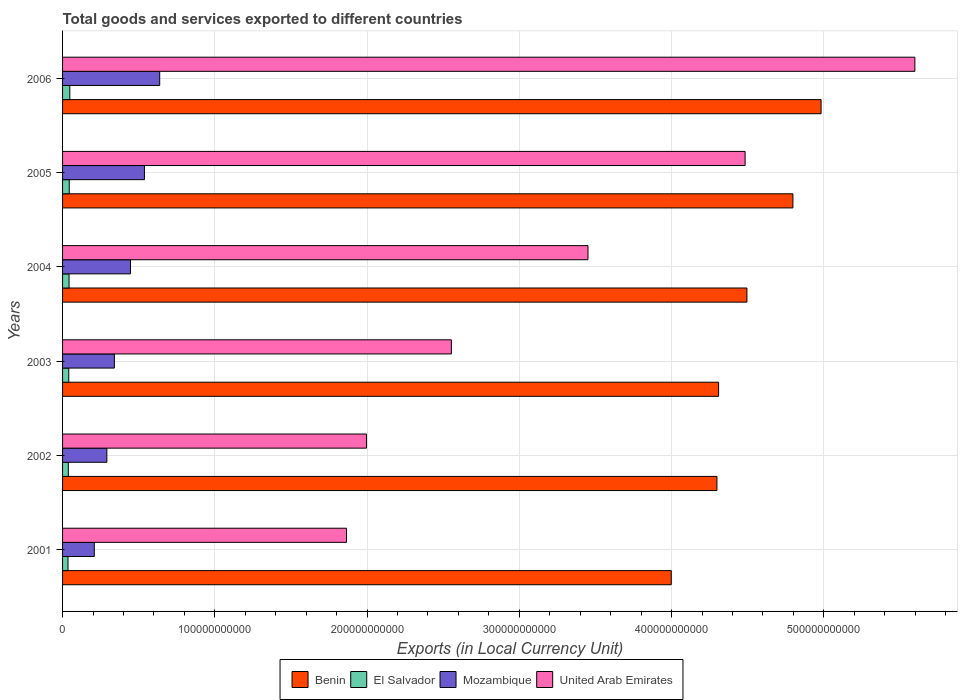How many groups of bars are there?
Your answer should be compact. 6. Are the number of bars per tick equal to the number of legend labels?
Give a very brief answer. Yes. Are the number of bars on each tick of the Y-axis equal?
Ensure brevity in your answer.  Yes. How many bars are there on the 4th tick from the top?
Ensure brevity in your answer.  4. What is the label of the 2nd group of bars from the top?
Give a very brief answer. 2005. In how many cases, is the number of bars for a given year not equal to the number of legend labels?
Make the answer very short. 0. What is the Amount of goods and services exports in El Salvador in 2002?
Give a very brief answer. 3.77e+09. Across all years, what is the maximum Amount of goods and services exports in El Salvador?
Your answer should be compact. 4.76e+09. Across all years, what is the minimum Amount of goods and services exports in United Arab Emirates?
Your answer should be very brief. 1.87e+11. In which year was the Amount of goods and services exports in United Arab Emirates maximum?
Make the answer very short. 2006. In which year was the Amount of goods and services exports in Mozambique minimum?
Your answer should be compact. 2001. What is the total Amount of goods and services exports in Mozambique in the graph?
Keep it short and to the point. 2.46e+11. What is the difference between the Amount of goods and services exports in United Arab Emirates in 2003 and that in 2005?
Make the answer very short. -1.93e+11. What is the difference between the Amount of goods and services exports in Mozambique in 2001 and the Amount of goods and services exports in El Salvador in 2003?
Keep it short and to the point. 1.68e+1. What is the average Amount of goods and services exports in Benin per year?
Provide a succinct answer. 4.48e+11. In the year 2002, what is the difference between the Amount of goods and services exports in El Salvador and Amount of goods and services exports in Mozambique?
Provide a succinct answer. -2.53e+1. What is the ratio of the Amount of goods and services exports in El Salvador in 2001 to that in 2005?
Ensure brevity in your answer.  0.81. Is the difference between the Amount of goods and services exports in El Salvador in 2001 and 2005 greater than the difference between the Amount of goods and services exports in Mozambique in 2001 and 2005?
Ensure brevity in your answer.  Yes. What is the difference between the highest and the second highest Amount of goods and services exports in United Arab Emirates?
Ensure brevity in your answer.  1.12e+11. What is the difference between the highest and the lowest Amount of goods and services exports in Mozambique?
Give a very brief answer. 4.30e+1. In how many years, is the Amount of goods and services exports in Mozambique greater than the average Amount of goods and services exports in Mozambique taken over all years?
Keep it short and to the point. 3. Is the sum of the Amount of goods and services exports in Benin in 2002 and 2003 greater than the maximum Amount of goods and services exports in El Salvador across all years?
Provide a short and direct response. Yes. Is it the case that in every year, the sum of the Amount of goods and services exports in United Arab Emirates and Amount of goods and services exports in Benin is greater than the sum of Amount of goods and services exports in Mozambique and Amount of goods and services exports in El Salvador?
Ensure brevity in your answer.  Yes. What does the 2nd bar from the top in 2003 represents?
Provide a short and direct response. Mozambique. What does the 3rd bar from the bottom in 2006 represents?
Offer a very short reply. Mozambique. Is it the case that in every year, the sum of the Amount of goods and services exports in United Arab Emirates and Amount of goods and services exports in El Salvador is greater than the Amount of goods and services exports in Mozambique?
Offer a terse response. Yes. What is the difference between two consecutive major ticks on the X-axis?
Your response must be concise. 1.00e+11. Are the values on the major ticks of X-axis written in scientific E-notation?
Offer a terse response. No. Does the graph contain any zero values?
Your answer should be compact. No. Does the graph contain grids?
Provide a short and direct response. Yes. Where does the legend appear in the graph?
Provide a short and direct response. Bottom center. How are the legend labels stacked?
Offer a very short reply. Horizontal. What is the title of the graph?
Offer a very short reply. Total goods and services exported to different countries. What is the label or title of the X-axis?
Provide a succinct answer. Exports (in Local Currency Unit). What is the label or title of the Y-axis?
Make the answer very short. Years. What is the Exports (in Local Currency Unit) in Benin in 2001?
Your response must be concise. 4.00e+11. What is the Exports (in Local Currency Unit) of El Salvador in 2001?
Your response must be concise. 3.57e+09. What is the Exports (in Local Currency Unit) of Mozambique in 2001?
Ensure brevity in your answer.  2.08e+1. What is the Exports (in Local Currency Unit) of United Arab Emirates in 2001?
Give a very brief answer. 1.87e+11. What is the Exports (in Local Currency Unit) in Benin in 2002?
Provide a succinct answer. 4.30e+11. What is the Exports (in Local Currency Unit) in El Salvador in 2002?
Provide a short and direct response. 3.77e+09. What is the Exports (in Local Currency Unit) of Mozambique in 2002?
Offer a terse response. 2.91e+1. What is the Exports (in Local Currency Unit) in United Arab Emirates in 2002?
Your answer should be compact. 2.00e+11. What is the Exports (in Local Currency Unit) of Benin in 2003?
Provide a succinct answer. 4.31e+11. What is the Exports (in Local Currency Unit) in El Salvador in 2003?
Give a very brief answer. 4.07e+09. What is the Exports (in Local Currency Unit) of Mozambique in 2003?
Provide a succinct answer. 3.40e+1. What is the Exports (in Local Currency Unit) of United Arab Emirates in 2003?
Your response must be concise. 2.55e+11. What is the Exports (in Local Currency Unit) in Benin in 2004?
Offer a very short reply. 4.50e+11. What is the Exports (in Local Currency Unit) in El Salvador in 2004?
Offer a terse response. 4.26e+09. What is the Exports (in Local Currency Unit) of Mozambique in 2004?
Your answer should be compact. 4.46e+1. What is the Exports (in Local Currency Unit) in United Arab Emirates in 2004?
Ensure brevity in your answer.  3.45e+11. What is the Exports (in Local Currency Unit) in Benin in 2005?
Provide a succinct answer. 4.80e+11. What is the Exports (in Local Currency Unit) in El Salvador in 2005?
Ensure brevity in your answer.  4.38e+09. What is the Exports (in Local Currency Unit) of Mozambique in 2005?
Your response must be concise. 5.38e+1. What is the Exports (in Local Currency Unit) in United Arab Emirates in 2005?
Your answer should be very brief. 4.48e+11. What is the Exports (in Local Currency Unit) of Benin in 2006?
Your answer should be compact. 4.98e+11. What is the Exports (in Local Currency Unit) of El Salvador in 2006?
Your answer should be compact. 4.76e+09. What is the Exports (in Local Currency Unit) in Mozambique in 2006?
Make the answer very short. 6.38e+1. What is the Exports (in Local Currency Unit) of United Arab Emirates in 2006?
Give a very brief answer. 5.60e+11. Across all years, what is the maximum Exports (in Local Currency Unit) of Benin?
Ensure brevity in your answer.  4.98e+11. Across all years, what is the maximum Exports (in Local Currency Unit) in El Salvador?
Give a very brief answer. 4.76e+09. Across all years, what is the maximum Exports (in Local Currency Unit) in Mozambique?
Your answer should be compact. 6.38e+1. Across all years, what is the maximum Exports (in Local Currency Unit) of United Arab Emirates?
Offer a very short reply. 5.60e+11. Across all years, what is the minimum Exports (in Local Currency Unit) of Benin?
Your answer should be very brief. 4.00e+11. Across all years, what is the minimum Exports (in Local Currency Unit) of El Salvador?
Provide a short and direct response. 3.57e+09. Across all years, what is the minimum Exports (in Local Currency Unit) in Mozambique?
Your response must be concise. 2.08e+1. Across all years, what is the minimum Exports (in Local Currency Unit) in United Arab Emirates?
Your response must be concise. 1.87e+11. What is the total Exports (in Local Currency Unit) in Benin in the graph?
Provide a succinct answer. 2.69e+12. What is the total Exports (in Local Currency Unit) of El Salvador in the graph?
Your answer should be compact. 2.48e+1. What is the total Exports (in Local Currency Unit) in Mozambique in the graph?
Make the answer very short. 2.46e+11. What is the total Exports (in Local Currency Unit) in United Arab Emirates in the graph?
Make the answer very short. 1.99e+12. What is the difference between the Exports (in Local Currency Unit) in Benin in 2001 and that in 2002?
Keep it short and to the point. -3.00e+1. What is the difference between the Exports (in Local Currency Unit) of El Salvador in 2001 and that in 2002?
Your response must be concise. -2.04e+08. What is the difference between the Exports (in Local Currency Unit) of Mozambique in 2001 and that in 2002?
Keep it short and to the point. -8.24e+09. What is the difference between the Exports (in Local Currency Unit) in United Arab Emirates in 2001 and that in 2002?
Keep it short and to the point. -1.31e+1. What is the difference between the Exports (in Local Currency Unit) in Benin in 2001 and that in 2003?
Your answer should be very brief. -3.11e+1. What is the difference between the Exports (in Local Currency Unit) in El Salvador in 2001 and that in 2003?
Your answer should be very brief. -5.05e+08. What is the difference between the Exports (in Local Currency Unit) of Mozambique in 2001 and that in 2003?
Make the answer very short. -1.32e+1. What is the difference between the Exports (in Local Currency Unit) of United Arab Emirates in 2001 and that in 2003?
Your response must be concise. -6.89e+1. What is the difference between the Exports (in Local Currency Unit) in Benin in 2001 and that in 2004?
Offer a very short reply. -4.97e+1. What is the difference between the Exports (in Local Currency Unit) of El Salvador in 2001 and that in 2004?
Offer a terse response. -6.91e+08. What is the difference between the Exports (in Local Currency Unit) in Mozambique in 2001 and that in 2004?
Give a very brief answer. -2.38e+1. What is the difference between the Exports (in Local Currency Unit) of United Arab Emirates in 2001 and that in 2004?
Provide a succinct answer. -1.59e+11. What is the difference between the Exports (in Local Currency Unit) of Benin in 2001 and that in 2005?
Offer a very short reply. -7.99e+1. What is the difference between the Exports (in Local Currency Unit) in El Salvador in 2001 and that in 2005?
Ensure brevity in your answer.  -8.15e+08. What is the difference between the Exports (in Local Currency Unit) in Mozambique in 2001 and that in 2005?
Your answer should be compact. -3.29e+1. What is the difference between the Exports (in Local Currency Unit) in United Arab Emirates in 2001 and that in 2005?
Provide a short and direct response. -2.62e+11. What is the difference between the Exports (in Local Currency Unit) in Benin in 2001 and that in 2006?
Give a very brief answer. -9.84e+1. What is the difference between the Exports (in Local Currency Unit) in El Salvador in 2001 and that in 2006?
Offer a terse response. -1.20e+09. What is the difference between the Exports (in Local Currency Unit) in Mozambique in 2001 and that in 2006?
Your answer should be very brief. -4.30e+1. What is the difference between the Exports (in Local Currency Unit) in United Arab Emirates in 2001 and that in 2006?
Your answer should be very brief. -3.73e+11. What is the difference between the Exports (in Local Currency Unit) in Benin in 2002 and that in 2003?
Your response must be concise. -1.10e+09. What is the difference between the Exports (in Local Currency Unit) in El Salvador in 2002 and that in 2003?
Provide a succinct answer. -3.01e+08. What is the difference between the Exports (in Local Currency Unit) of Mozambique in 2002 and that in 2003?
Offer a very short reply. -4.95e+09. What is the difference between the Exports (in Local Currency Unit) in United Arab Emirates in 2002 and that in 2003?
Keep it short and to the point. -5.57e+1. What is the difference between the Exports (in Local Currency Unit) in Benin in 2002 and that in 2004?
Offer a very short reply. -1.97e+1. What is the difference between the Exports (in Local Currency Unit) in El Salvador in 2002 and that in 2004?
Make the answer very short. -4.87e+08. What is the difference between the Exports (in Local Currency Unit) in Mozambique in 2002 and that in 2004?
Ensure brevity in your answer.  -1.55e+1. What is the difference between the Exports (in Local Currency Unit) of United Arab Emirates in 2002 and that in 2004?
Keep it short and to the point. -1.45e+11. What is the difference between the Exports (in Local Currency Unit) in Benin in 2002 and that in 2005?
Offer a very short reply. -4.99e+1. What is the difference between the Exports (in Local Currency Unit) in El Salvador in 2002 and that in 2005?
Offer a terse response. -6.11e+08. What is the difference between the Exports (in Local Currency Unit) of Mozambique in 2002 and that in 2005?
Your answer should be compact. -2.47e+1. What is the difference between the Exports (in Local Currency Unit) in United Arab Emirates in 2002 and that in 2005?
Ensure brevity in your answer.  -2.49e+11. What is the difference between the Exports (in Local Currency Unit) in Benin in 2002 and that in 2006?
Keep it short and to the point. -6.84e+1. What is the difference between the Exports (in Local Currency Unit) of El Salvador in 2002 and that in 2006?
Provide a succinct answer. -9.92e+08. What is the difference between the Exports (in Local Currency Unit) of Mozambique in 2002 and that in 2006?
Your answer should be compact. -3.47e+1. What is the difference between the Exports (in Local Currency Unit) in United Arab Emirates in 2002 and that in 2006?
Offer a very short reply. -3.60e+11. What is the difference between the Exports (in Local Currency Unit) of Benin in 2003 and that in 2004?
Provide a short and direct response. -1.86e+1. What is the difference between the Exports (in Local Currency Unit) in El Salvador in 2003 and that in 2004?
Provide a succinct answer. -1.86e+08. What is the difference between the Exports (in Local Currency Unit) of Mozambique in 2003 and that in 2004?
Your answer should be compact. -1.06e+1. What is the difference between the Exports (in Local Currency Unit) of United Arab Emirates in 2003 and that in 2004?
Offer a terse response. -8.97e+1. What is the difference between the Exports (in Local Currency Unit) of Benin in 2003 and that in 2005?
Your response must be concise. -4.88e+1. What is the difference between the Exports (in Local Currency Unit) in El Salvador in 2003 and that in 2005?
Your answer should be very brief. -3.10e+08. What is the difference between the Exports (in Local Currency Unit) of Mozambique in 2003 and that in 2005?
Your answer should be very brief. -1.97e+1. What is the difference between the Exports (in Local Currency Unit) of United Arab Emirates in 2003 and that in 2005?
Offer a terse response. -1.93e+11. What is the difference between the Exports (in Local Currency Unit) in Benin in 2003 and that in 2006?
Give a very brief answer. -6.73e+1. What is the difference between the Exports (in Local Currency Unit) in El Salvador in 2003 and that in 2006?
Provide a succinct answer. -6.91e+08. What is the difference between the Exports (in Local Currency Unit) of Mozambique in 2003 and that in 2006?
Your answer should be compact. -2.98e+1. What is the difference between the Exports (in Local Currency Unit) of United Arab Emirates in 2003 and that in 2006?
Give a very brief answer. -3.04e+11. What is the difference between the Exports (in Local Currency Unit) of Benin in 2004 and that in 2005?
Ensure brevity in your answer.  -3.02e+1. What is the difference between the Exports (in Local Currency Unit) in El Salvador in 2004 and that in 2005?
Ensure brevity in your answer.  -1.24e+08. What is the difference between the Exports (in Local Currency Unit) in Mozambique in 2004 and that in 2005?
Your answer should be very brief. -9.15e+09. What is the difference between the Exports (in Local Currency Unit) of United Arab Emirates in 2004 and that in 2005?
Your response must be concise. -1.03e+11. What is the difference between the Exports (in Local Currency Unit) in Benin in 2004 and that in 2006?
Your answer should be very brief. -4.87e+1. What is the difference between the Exports (in Local Currency Unit) in El Salvador in 2004 and that in 2006?
Provide a succinct answer. -5.05e+08. What is the difference between the Exports (in Local Currency Unit) in Mozambique in 2004 and that in 2006?
Offer a very short reply. -1.92e+1. What is the difference between the Exports (in Local Currency Unit) of United Arab Emirates in 2004 and that in 2006?
Offer a very short reply. -2.15e+11. What is the difference between the Exports (in Local Currency Unit) of Benin in 2005 and that in 2006?
Your answer should be compact. -1.85e+1. What is the difference between the Exports (in Local Currency Unit) of El Salvador in 2005 and that in 2006?
Ensure brevity in your answer.  -3.81e+08. What is the difference between the Exports (in Local Currency Unit) in Mozambique in 2005 and that in 2006?
Make the answer very short. -1.00e+1. What is the difference between the Exports (in Local Currency Unit) in United Arab Emirates in 2005 and that in 2006?
Give a very brief answer. -1.12e+11. What is the difference between the Exports (in Local Currency Unit) of Benin in 2001 and the Exports (in Local Currency Unit) of El Salvador in 2002?
Your response must be concise. 3.96e+11. What is the difference between the Exports (in Local Currency Unit) of Benin in 2001 and the Exports (in Local Currency Unit) of Mozambique in 2002?
Make the answer very short. 3.71e+11. What is the difference between the Exports (in Local Currency Unit) in Benin in 2001 and the Exports (in Local Currency Unit) in United Arab Emirates in 2002?
Make the answer very short. 2.00e+11. What is the difference between the Exports (in Local Currency Unit) in El Salvador in 2001 and the Exports (in Local Currency Unit) in Mozambique in 2002?
Offer a terse response. -2.55e+1. What is the difference between the Exports (in Local Currency Unit) of El Salvador in 2001 and the Exports (in Local Currency Unit) of United Arab Emirates in 2002?
Offer a very short reply. -1.96e+11. What is the difference between the Exports (in Local Currency Unit) in Mozambique in 2001 and the Exports (in Local Currency Unit) in United Arab Emirates in 2002?
Provide a succinct answer. -1.79e+11. What is the difference between the Exports (in Local Currency Unit) in Benin in 2001 and the Exports (in Local Currency Unit) in El Salvador in 2003?
Make the answer very short. 3.96e+11. What is the difference between the Exports (in Local Currency Unit) in Benin in 2001 and the Exports (in Local Currency Unit) in Mozambique in 2003?
Offer a terse response. 3.66e+11. What is the difference between the Exports (in Local Currency Unit) of Benin in 2001 and the Exports (in Local Currency Unit) of United Arab Emirates in 2003?
Give a very brief answer. 1.44e+11. What is the difference between the Exports (in Local Currency Unit) in El Salvador in 2001 and the Exports (in Local Currency Unit) in Mozambique in 2003?
Your answer should be very brief. -3.05e+1. What is the difference between the Exports (in Local Currency Unit) of El Salvador in 2001 and the Exports (in Local Currency Unit) of United Arab Emirates in 2003?
Keep it short and to the point. -2.52e+11. What is the difference between the Exports (in Local Currency Unit) of Mozambique in 2001 and the Exports (in Local Currency Unit) of United Arab Emirates in 2003?
Offer a very short reply. -2.35e+11. What is the difference between the Exports (in Local Currency Unit) in Benin in 2001 and the Exports (in Local Currency Unit) in El Salvador in 2004?
Provide a succinct answer. 3.96e+11. What is the difference between the Exports (in Local Currency Unit) of Benin in 2001 and the Exports (in Local Currency Unit) of Mozambique in 2004?
Offer a very short reply. 3.55e+11. What is the difference between the Exports (in Local Currency Unit) in Benin in 2001 and the Exports (in Local Currency Unit) in United Arab Emirates in 2004?
Give a very brief answer. 5.47e+1. What is the difference between the Exports (in Local Currency Unit) in El Salvador in 2001 and the Exports (in Local Currency Unit) in Mozambique in 2004?
Provide a succinct answer. -4.11e+1. What is the difference between the Exports (in Local Currency Unit) in El Salvador in 2001 and the Exports (in Local Currency Unit) in United Arab Emirates in 2004?
Give a very brief answer. -3.42e+11. What is the difference between the Exports (in Local Currency Unit) in Mozambique in 2001 and the Exports (in Local Currency Unit) in United Arab Emirates in 2004?
Provide a succinct answer. -3.24e+11. What is the difference between the Exports (in Local Currency Unit) of Benin in 2001 and the Exports (in Local Currency Unit) of El Salvador in 2005?
Provide a succinct answer. 3.95e+11. What is the difference between the Exports (in Local Currency Unit) in Benin in 2001 and the Exports (in Local Currency Unit) in Mozambique in 2005?
Keep it short and to the point. 3.46e+11. What is the difference between the Exports (in Local Currency Unit) of Benin in 2001 and the Exports (in Local Currency Unit) of United Arab Emirates in 2005?
Give a very brief answer. -4.85e+1. What is the difference between the Exports (in Local Currency Unit) of El Salvador in 2001 and the Exports (in Local Currency Unit) of Mozambique in 2005?
Give a very brief answer. -5.02e+1. What is the difference between the Exports (in Local Currency Unit) of El Salvador in 2001 and the Exports (in Local Currency Unit) of United Arab Emirates in 2005?
Your answer should be very brief. -4.45e+11. What is the difference between the Exports (in Local Currency Unit) of Mozambique in 2001 and the Exports (in Local Currency Unit) of United Arab Emirates in 2005?
Your answer should be compact. -4.27e+11. What is the difference between the Exports (in Local Currency Unit) in Benin in 2001 and the Exports (in Local Currency Unit) in El Salvador in 2006?
Your answer should be compact. 3.95e+11. What is the difference between the Exports (in Local Currency Unit) of Benin in 2001 and the Exports (in Local Currency Unit) of Mozambique in 2006?
Offer a very short reply. 3.36e+11. What is the difference between the Exports (in Local Currency Unit) in Benin in 2001 and the Exports (in Local Currency Unit) in United Arab Emirates in 2006?
Offer a very short reply. -1.60e+11. What is the difference between the Exports (in Local Currency Unit) in El Salvador in 2001 and the Exports (in Local Currency Unit) in Mozambique in 2006?
Provide a succinct answer. -6.02e+1. What is the difference between the Exports (in Local Currency Unit) in El Salvador in 2001 and the Exports (in Local Currency Unit) in United Arab Emirates in 2006?
Make the answer very short. -5.56e+11. What is the difference between the Exports (in Local Currency Unit) of Mozambique in 2001 and the Exports (in Local Currency Unit) of United Arab Emirates in 2006?
Your answer should be very brief. -5.39e+11. What is the difference between the Exports (in Local Currency Unit) in Benin in 2002 and the Exports (in Local Currency Unit) in El Salvador in 2003?
Make the answer very short. 4.26e+11. What is the difference between the Exports (in Local Currency Unit) in Benin in 2002 and the Exports (in Local Currency Unit) in Mozambique in 2003?
Ensure brevity in your answer.  3.96e+11. What is the difference between the Exports (in Local Currency Unit) in Benin in 2002 and the Exports (in Local Currency Unit) in United Arab Emirates in 2003?
Provide a short and direct response. 1.74e+11. What is the difference between the Exports (in Local Currency Unit) in El Salvador in 2002 and the Exports (in Local Currency Unit) in Mozambique in 2003?
Give a very brief answer. -3.03e+1. What is the difference between the Exports (in Local Currency Unit) of El Salvador in 2002 and the Exports (in Local Currency Unit) of United Arab Emirates in 2003?
Give a very brief answer. -2.52e+11. What is the difference between the Exports (in Local Currency Unit) of Mozambique in 2002 and the Exports (in Local Currency Unit) of United Arab Emirates in 2003?
Provide a short and direct response. -2.26e+11. What is the difference between the Exports (in Local Currency Unit) of Benin in 2002 and the Exports (in Local Currency Unit) of El Salvador in 2004?
Offer a very short reply. 4.26e+11. What is the difference between the Exports (in Local Currency Unit) of Benin in 2002 and the Exports (in Local Currency Unit) of Mozambique in 2004?
Make the answer very short. 3.85e+11. What is the difference between the Exports (in Local Currency Unit) in Benin in 2002 and the Exports (in Local Currency Unit) in United Arab Emirates in 2004?
Offer a very short reply. 8.47e+1. What is the difference between the Exports (in Local Currency Unit) in El Salvador in 2002 and the Exports (in Local Currency Unit) in Mozambique in 2004?
Provide a succinct answer. -4.09e+1. What is the difference between the Exports (in Local Currency Unit) of El Salvador in 2002 and the Exports (in Local Currency Unit) of United Arab Emirates in 2004?
Provide a short and direct response. -3.41e+11. What is the difference between the Exports (in Local Currency Unit) of Mozambique in 2002 and the Exports (in Local Currency Unit) of United Arab Emirates in 2004?
Ensure brevity in your answer.  -3.16e+11. What is the difference between the Exports (in Local Currency Unit) in Benin in 2002 and the Exports (in Local Currency Unit) in El Salvador in 2005?
Offer a very short reply. 4.25e+11. What is the difference between the Exports (in Local Currency Unit) in Benin in 2002 and the Exports (in Local Currency Unit) in Mozambique in 2005?
Your answer should be compact. 3.76e+11. What is the difference between the Exports (in Local Currency Unit) in Benin in 2002 and the Exports (in Local Currency Unit) in United Arab Emirates in 2005?
Keep it short and to the point. -1.85e+1. What is the difference between the Exports (in Local Currency Unit) in El Salvador in 2002 and the Exports (in Local Currency Unit) in Mozambique in 2005?
Provide a short and direct response. -5.00e+1. What is the difference between the Exports (in Local Currency Unit) in El Salvador in 2002 and the Exports (in Local Currency Unit) in United Arab Emirates in 2005?
Ensure brevity in your answer.  -4.45e+11. What is the difference between the Exports (in Local Currency Unit) in Mozambique in 2002 and the Exports (in Local Currency Unit) in United Arab Emirates in 2005?
Make the answer very short. -4.19e+11. What is the difference between the Exports (in Local Currency Unit) in Benin in 2002 and the Exports (in Local Currency Unit) in El Salvador in 2006?
Your answer should be very brief. 4.25e+11. What is the difference between the Exports (in Local Currency Unit) in Benin in 2002 and the Exports (in Local Currency Unit) in Mozambique in 2006?
Keep it short and to the point. 3.66e+11. What is the difference between the Exports (in Local Currency Unit) of Benin in 2002 and the Exports (in Local Currency Unit) of United Arab Emirates in 2006?
Ensure brevity in your answer.  -1.30e+11. What is the difference between the Exports (in Local Currency Unit) in El Salvador in 2002 and the Exports (in Local Currency Unit) in Mozambique in 2006?
Provide a succinct answer. -6.00e+1. What is the difference between the Exports (in Local Currency Unit) in El Salvador in 2002 and the Exports (in Local Currency Unit) in United Arab Emirates in 2006?
Ensure brevity in your answer.  -5.56e+11. What is the difference between the Exports (in Local Currency Unit) of Mozambique in 2002 and the Exports (in Local Currency Unit) of United Arab Emirates in 2006?
Your response must be concise. -5.31e+11. What is the difference between the Exports (in Local Currency Unit) of Benin in 2003 and the Exports (in Local Currency Unit) of El Salvador in 2004?
Your answer should be compact. 4.27e+11. What is the difference between the Exports (in Local Currency Unit) of Benin in 2003 and the Exports (in Local Currency Unit) of Mozambique in 2004?
Provide a short and direct response. 3.86e+11. What is the difference between the Exports (in Local Currency Unit) of Benin in 2003 and the Exports (in Local Currency Unit) of United Arab Emirates in 2004?
Your response must be concise. 8.58e+1. What is the difference between the Exports (in Local Currency Unit) of El Salvador in 2003 and the Exports (in Local Currency Unit) of Mozambique in 2004?
Keep it short and to the point. -4.06e+1. What is the difference between the Exports (in Local Currency Unit) of El Salvador in 2003 and the Exports (in Local Currency Unit) of United Arab Emirates in 2004?
Keep it short and to the point. -3.41e+11. What is the difference between the Exports (in Local Currency Unit) in Mozambique in 2003 and the Exports (in Local Currency Unit) in United Arab Emirates in 2004?
Ensure brevity in your answer.  -3.11e+11. What is the difference between the Exports (in Local Currency Unit) of Benin in 2003 and the Exports (in Local Currency Unit) of El Salvador in 2005?
Ensure brevity in your answer.  4.27e+11. What is the difference between the Exports (in Local Currency Unit) in Benin in 2003 and the Exports (in Local Currency Unit) in Mozambique in 2005?
Your answer should be compact. 3.77e+11. What is the difference between the Exports (in Local Currency Unit) of Benin in 2003 and the Exports (in Local Currency Unit) of United Arab Emirates in 2005?
Keep it short and to the point. -1.74e+1. What is the difference between the Exports (in Local Currency Unit) of El Salvador in 2003 and the Exports (in Local Currency Unit) of Mozambique in 2005?
Your answer should be compact. -4.97e+1. What is the difference between the Exports (in Local Currency Unit) of El Salvador in 2003 and the Exports (in Local Currency Unit) of United Arab Emirates in 2005?
Your answer should be compact. -4.44e+11. What is the difference between the Exports (in Local Currency Unit) of Mozambique in 2003 and the Exports (in Local Currency Unit) of United Arab Emirates in 2005?
Your answer should be compact. -4.14e+11. What is the difference between the Exports (in Local Currency Unit) in Benin in 2003 and the Exports (in Local Currency Unit) in El Salvador in 2006?
Your answer should be very brief. 4.26e+11. What is the difference between the Exports (in Local Currency Unit) in Benin in 2003 and the Exports (in Local Currency Unit) in Mozambique in 2006?
Provide a succinct answer. 3.67e+11. What is the difference between the Exports (in Local Currency Unit) in Benin in 2003 and the Exports (in Local Currency Unit) in United Arab Emirates in 2006?
Keep it short and to the point. -1.29e+11. What is the difference between the Exports (in Local Currency Unit) in El Salvador in 2003 and the Exports (in Local Currency Unit) in Mozambique in 2006?
Give a very brief answer. -5.97e+1. What is the difference between the Exports (in Local Currency Unit) of El Salvador in 2003 and the Exports (in Local Currency Unit) of United Arab Emirates in 2006?
Make the answer very short. -5.56e+11. What is the difference between the Exports (in Local Currency Unit) of Mozambique in 2003 and the Exports (in Local Currency Unit) of United Arab Emirates in 2006?
Ensure brevity in your answer.  -5.26e+11. What is the difference between the Exports (in Local Currency Unit) in Benin in 2004 and the Exports (in Local Currency Unit) in El Salvador in 2005?
Your response must be concise. 4.45e+11. What is the difference between the Exports (in Local Currency Unit) of Benin in 2004 and the Exports (in Local Currency Unit) of Mozambique in 2005?
Your answer should be compact. 3.96e+11. What is the difference between the Exports (in Local Currency Unit) of Benin in 2004 and the Exports (in Local Currency Unit) of United Arab Emirates in 2005?
Provide a succinct answer. 1.20e+09. What is the difference between the Exports (in Local Currency Unit) in El Salvador in 2004 and the Exports (in Local Currency Unit) in Mozambique in 2005?
Ensure brevity in your answer.  -4.95e+1. What is the difference between the Exports (in Local Currency Unit) in El Salvador in 2004 and the Exports (in Local Currency Unit) in United Arab Emirates in 2005?
Your answer should be compact. -4.44e+11. What is the difference between the Exports (in Local Currency Unit) of Mozambique in 2004 and the Exports (in Local Currency Unit) of United Arab Emirates in 2005?
Ensure brevity in your answer.  -4.04e+11. What is the difference between the Exports (in Local Currency Unit) in Benin in 2004 and the Exports (in Local Currency Unit) in El Salvador in 2006?
Your answer should be very brief. 4.45e+11. What is the difference between the Exports (in Local Currency Unit) of Benin in 2004 and the Exports (in Local Currency Unit) of Mozambique in 2006?
Make the answer very short. 3.86e+11. What is the difference between the Exports (in Local Currency Unit) in Benin in 2004 and the Exports (in Local Currency Unit) in United Arab Emirates in 2006?
Your response must be concise. -1.10e+11. What is the difference between the Exports (in Local Currency Unit) in El Salvador in 2004 and the Exports (in Local Currency Unit) in Mozambique in 2006?
Ensure brevity in your answer.  -5.95e+1. What is the difference between the Exports (in Local Currency Unit) in El Salvador in 2004 and the Exports (in Local Currency Unit) in United Arab Emirates in 2006?
Make the answer very short. -5.56e+11. What is the difference between the Exports (in Local Currency Unit) in Mozambique in 2004 and the Exports (in Local Currency Unit) in United Arab Emirates in 2006?
Offer a very short reply. -5.15e+11. What is the difference between the Exports (in Local Currency Unit) in Benin in 2005 and the Exports (in Local Currency Unit) in El Salvador in 2006?
Make the answer very short. 4.75e+11. What is the difference between the Exports (in Local Currency Unit) of Benin in 2005 and the Exports (in Local Currency Unit) of Mozambique in 2006?
Offer a terse response. 4.16e+11. What is the difference between the Exports (in Local Currency Unit) of Benin in 2005 and the Exports (in Local Currency Unit) of United Arab Emirates in 2006?
Your answer should be very brief. -8.01e+1. What is the difference between the Exports (in Local Currency Unit) of El Salvador in 2005 and the Exports (in Local Currency Unit) of Mozambique in 2006?
Provide a succinct answer. -5.94e+1. What is the difference between the Exports (in Local Currency Unit) of El Salvador in 2005 and the Exports (in Local Currency Unit) of United Arab Emirates in 2006?
Keep it short and to the point. -5.55e+11. What is the difference between the Exports (in Local Currency Unit) in Mozambique in 2005 and the Exports (in Local Currency Unit) in United Arab Emirates in 2006?
Offer a terse response. -5.06e+11. What is the average Exports (in Local Currency Unit) in Benin per year?
Your response must be concise. 4.48e+11. What is the average Exports (in Local Currency Unit) in El Salvador per year?
Offer a terse response. 4.14e+09. What is the average Exports (in Local Currency Unit) in Mozambique per year?
Keep it short and to the point. 4.10e+1. What is the average Exports (in Local Currency Unit) in United Arab Emirates per year?
Provide a short and direct response. 3.32e+11. In the year 2001, what is the difference between the Exports (in Local Currency Unit) of Benin and Exports (in Local Currency Unit) of El Salvador?
Offer a terse response. 3.96e+11. In the year 2001, what is the difference between the Exports (in Local Currency Unit) in Benin and Exports (in Local Currency Unit) in Mozambique?
Provide a short and direct response. 3.79e+11. In the year 2001, what is the difference between the Exports (in Local Currency Unit) in Benin and Exports (in Local Currency Unit) in United Arab Emirates?
Offer a very short reply. 2.13e+11. In the year 2001, what is the difference between the Exports (in Local Currency Unit) in El Salvador and Exports (in Local Currency Unit) in Mozambique?
Offer a terse response. -1.73e+1. In the year 2001, what is the difference between the Exports (in Local Currency Unit) in El Salvador and Exports (in Local Currency Unit) in United Arab Emirates?
Ensure brevity in your answer.  -1.83e+11. In the year 2001, what is the difference between the Exports (in Local Currency Unit) in Mozambique and Exports (in Local Currency Unit) in United Arab Emirates?
Your answer should be compact. -1.66e+11. In the year 2002, what is the difference between the Exports (in Local Currency Unit) of Benin and Exports (in Local Currency Unit) of El Salvador?
Your answer should be compact. 4.26e+11. In the year 2002, what is the difference between the Exports (in Local Currency Unit) of Benin and Exports (in Local Currency Unit) of Mozambique?
Ensure brevity in your answer.  4.01e+11. In the year 2002, what is the difference between the Exports (in Local Currency Unit) in Benin and Exports (in Local Currency Unit) in United Arab Emirates?
Give a very brief answer. 2.30e+11. In the year 2002, what is the difference between the Exports (in Local Currency Unit) of El Salvador and Exports (in Local Currency Unit) of Mozambique?
Keep it short and to the point. -2.53e+1. In the year 2002, what is the difference between the Exports (in Local Currency Unit) in El Salvador and Exports (in Local Currency Unit) in United Arab Emirates?
Your response must be concise. -1.96e+11. In the year 2002, what is the difference between the Exports (in Local Currency Unit) in Mozambique and Exports (in Local Currency Unit) in United Arab Emirates?
Provide a short and direct response. -1.71e+11. In the year 2003, what is the difference between the Exports (in Local Currency Unit) in Benin and Exports (in Local Currency Unit) in El Salvador?
Provide a succinct answer. 4.27e+11. In the year 2003, what is the difference between the Exports (in Local Currency Unit) in Benin and Exports (in Local Currency Unit) in Mozambique?
Offer a terse response. 3.97e+11. In the year 2003, what is the difference between the Exports (in Local Currency Unit) of Benin and Exports (in Local Currency Unit) of United Arab Emirates?
Your response must be concise. 1.76e+11. In the year 2003, what is the difference between the Exports (in Local Currency Unit) in El Salvador and Exports (in Local Currency Unit) in Mozambique?
Provide a succinct answer. -3.00e+1. In the year 2003, what is the difference between the Exports (in Local Currency Unit) of El Salvador and Exports (in Local Currency Unit) of United Arab Emirates?
Give a very brief answer. -2.51e+11. In the year 2003, what is the difference between the Exports (in Local Currency Unit) of Mozambique and Exports (in Local Currency Unit) of United Arab Emirates?
Make the answer very short. -2.21e+11. In the year 2004, what is the difference between the Exports (in Local Currency Unit) in Benin and Exports (in Local Currency Unit) in El Salvador?
Your answer should be very brief. 4.45e+11. In the year 2004, what is the difference between the Exports (in Local Currency Unit) of Benin and Exports (in Local Currency Unit) of Mozambique?
Provide a succinct answer. 4.05e+11. In the year 2004, what is the difference between the Exports (in Local Currency Unit) of Benin and Exports (in Local Currency Unit) of United Arab Emirates?
Your answer should be compact. 1.04e+11. In the year 2004, what is the difference between the Exports (in Local Currency Unit) of El Salvador and Exports (in Local Currency Unit) of Mozambique?
Your response must be concise. -4.04e+1. In the year 2004, what is the difference between the Exports (in Local Currency Unit) of El Salvador and Exports (in Local Currency Unit) of United Arab Emirates?
Ensure brevity in your answer.  -3.41e+11. In the year 2004, what is the difference between the Exports (in Local Currency Unit) of Mozambique and Exports (in Local Currency Unit) of United Arab Emirates?
Your answer should be compact. -3.00e+11. In the year 2005, what is the difference between the Exports (in Local Currency Unit) in Benin and Exports (in Local Currency Unit) in El Salvador?
Your answer should be compact. 4.75e+11. In the year 2005, what is the difference between the Exports (in Local Currency Unit) in Benin and Exports (in Local Currency Unit) in Mozambique?
Your response must be concise. 4.26e+11. In the year 2005, what is the difference between the Exports (in Local Currency Unit) of Benin and Exports (in Local Currency Unit) of United Arab Emirates?
Your answer should be compact. 3.14e+1. In the year 2005, what is the difference between the Exports (in Local Currency Unit) of El Salvador and Exports (in Local Currency Unit) of Mozambique?
Provide a short and direct response. -4.94e+1. In the year 2005, what is the difference between the Exports (in Local Currency Unit) in El Salvador and Exports (in Local Currency Unit) in United Arab Emirates?
Your answer should be compact. -4.44e+11. In the year 2005, what is the difference between the Exports (in Local Currency Unit) in Mozambique and Exports (in Local Currency Unit) in United Arab Emirates?
Provide a short and direct response. -3.95e+11. In the year 2006, what is the difference between the Exports (in Local Currency Unit) of Benin and Exports (in Local Currency Unit) of El Salvador?
Make the answer very short. 4.93e+11. In the year 2006, what is the difference between the Exports (in Local Currency Unit) in Benin and Exports (in Local Currency Unit) in Mozambique?
Your response must be concise. 4.34e+11. In the year 2006, what is the difference between the Exports (in Local Currency Unit) in Benin and Exports (in Local Currency Unit) in United Arab Emirates?
Keep it short and to the point. -6.16e+1. In the year 2006, what is the difference between the Exports (in Local Currency Unit) of El Salvador and Exports (in Local Currency Unit) of Mozambique?
Your answer should be compact. -5.90e+1. In the year 2006, what is the difference between the Exports (in Local Currency Unit) in El Salvador and Exports (in Local Currency Unit) in United Arab Emirates?
Give a very brief answer. -5.55e+11. In the year 2006, what is the difference between the Exports (in Local Currency Unit) of Mozambique and Exports (in Local Currency Unit) of United Arab Emirates?
Provide a succinct answer. -4.96e+11. What is the ratio of the Exports (in Local Currency Unit) of Benin in 2001 to that in 2002?
Offer a terse response. 0.93. What is the ratio of the Exports (in Local Currency Unit) in El Salvador in 2001 to that in 2002?
Provide a short and direct response. 0.95. What is the ratio of the Exports (in Local Currency Unit) in Mozambique in 2001 to that in 2002?
Provide a succinct answer. 0.72. What is the ratio of the Exports (in Local Currency Unit) of United Arab Emirates in 2001 to that in 2002?
Your answer should be very brief. 0.93. What is the ratio of the Exports (in Local Currency Unit) in Benin in 2001 to that in 2003?
Make the answer very short. 0.93. What is the ratio of the Exports (in Local Currency Unit) of El Salvador in 2001 to that in 2003?
Give a very brief answer. 0.88. What is the ratio of the Exports (in Local Currency Unit) in Mozambique in 2001 to that in 2003?
Give a very brief answer. 0.61. What is the ratio of the Exports (in Local Currency Unit) of United Arab Emirates in 2001 to that in 2003?
Your answer should be very brief. 0.73. What is the ratio of the Exports (in Local Currency Unit) in Benin in 2001 to that in 2004?
Offer a very short reply. 0.89. What is the ratio of the Exports (in Local Currency Unit) in El Salvador in 2001 to that in 2004?
Provide a short and direct response. 0.84. What is the ratio of the Exports (in Local Currency Unit) of Mozambique in 2001 to that in 2004?
Keep it short and to the point. 0.47. What is the ratio of the Exports (in Local Currency Unit) of United Arab Emirates in 2001 to that in 2004?
Offer a very short reply. 0.54. What is the ratio of the Exports (in Local Currency Unit) in Benin in 2001 to that in 2005?
Make the answer very short. 0.83. What is the ratio of the Exports (in Local Currency Unit) in El Salvador in 2001 to that in 2005?
Offer a very short reply. 0.81. What is the ratio of the Exports (in Local Currency Unit) in Mozambique in 2001 to that in 2005?
Your response must be concise. 0.39. What is the ratio of the Exports (in Local Currency Unit) of United Arab Emirates in 2001 to that in 2005?
Give a very brief answer. 0.42. What is the ratio of the Exports (in Local Currency Unit) in Benin in 2001 to that in 2006?
Your answer should be compact. 0.8. What is the ratio of the Exports (in Local Currency Unit) in El Salvador in 2001 to that in 2006?
Provide a short and direct response. 0.75. What is the ratio of the Exports (in Local Currency Unit) of Mozambique in 2001 to that in 2006?
Offer a terse response. 0.33. What is the ratio of the Exports (in Local Currency Unit) of United Arab Emirates in 2001 to that in 2006?
Give a very brief answer. 0.33. What is the ratio of the Exports (in Local Currency Unit) in El Salvador in 2002 to that in 2003?
Give a very brief answer. 0.93. What is the ratio of the Exports (in Local Currency Unit) in Mozambique in 2002 to that in 2003?
Your answer should be very brief. 0.85. What is the ratio of the Exports (in Local Currency Unit) of United Arab Emirates in 2002 to that in 2003?
Keep it short and to the point. 0.78. What is the ratio of the Exports (in Local Currency Unit) in Benin in 2002 to that in 2004?
Provide a short and direct response. 0.96. What is the ratio of the Exports (in Local Currency Unit) of El Salvador in 2002 to that in 2004?
Your answer should be compact. 0.89. What is the ratio of the Exports (in Local Currency Unit) of Mozambique in 2002 to that in 2004?
Make the answer very short. 0.65. What is the ratio of the Exports (in Local Currency Unit) in United Arab Emirates in 2002 to that in 2004?
Make the answer very short. 0.58. What is the ratio of the Exports (in Local Currency Unit) of Benin in 2002 to that in 2005?
Your answer should be compact. 0.9. What is the ratio of the Exports (in Local Currency Unit) in El Salvador in 2002 to that in 2005?
Ensure brevity in your answer.  0.86. What is the ratio of the Exports (in Local Currency Unit) in Mozambique in 2002 to that in 2005?
Offer a terse response. 0.54. What is the ratio of the Exports (in Local Currency Unit) in United Arab Emirates in 2002 to that in 2005?
Your answer should be compact. 0.45. What is the ratio of the Exports (in Local Currency Unit) in Benin in 2002 to that in 2006?
Give a very brief answer. 0.86. What is the ratio of the Exports (in Local Currency Unit) in El Salvador in 2002 to that in 2006?
Provide a succinct answer. 0.79. What is the ratio of the Exports (in Local Currency Unit) of Mozambique in 2002 to that in 2006?
Your answer should be compact. 0.46. What is the ratio of the Exports (in Local Currency Unit) in United Arab Emirates in 2002 to that in 2006?
Provide a short and direct response. 0.36. What is the ratio of the Exports (in Local Currency Unit) of Benin in 2003 to that in 2004?
Ensure brevity in your answer.  0.96. What is the ratio of the Exports (in Local Currency Unit) in El Salvador in 2003 to that in 2004?
Provide a succinct answer. 0.96. What is the ratio of the Exports (in Local Currency Unit) in Mozambique in 2003 to that in 2004?
Keep it short and to the point. 0.76. What is the ratio of the Exports (in Local Currency Unit) in United Arab Emirates in 2003 to that in 2004?
Offer a terse response. 0.74. What is the ratio of the Exports (in Local Currency Unit) of Benin in 2003 to that in 2005?
Keep it short and to the point. 0.9. What is the ratio of the Exports (in Local Currency Unit) in El Salvador in 2003 to that in 2005?
Keep it short and to the point. 0.93. What is the ratio of the Exports (in Local Currency Unit) of Mozambique in 2003 to that in 2005?
Offer a very short reply. 0.63. What is the ratio of the Exports (in Local Currency Unit) in United Arab Emirates in 2003 to that in 2005?
Your answer should be compact. 0.57. What is the ratio of the Exports (in Local Currency Unit) in Benin in 2003 to that in 2006?
Your response must be concise. 0.86. What is the ratio of the Exports (in Local Currency Unit) in El Salvador in 2003 to that in 2006?
Offer a terse response. 0.85. What is the ratio of the Exports (in Local Currency Unit) in Mozambique in 2003 to that in 2006?
Ensure brevity in your answer.  0.53. What is the ratio of the Exports (in Local Currency Unit) in United Arab Emirates in 2003 to that in 2006?
Provide a short and direct response. 0.46. What is the ratio of the Exports (in Local Currency Unit) in Benin in 2004 to that in 2005?
Ensure brevity in your answer.  0.94. What is the ratio of the Exports (in Local Currency Unit) in El Salvador in 2004 to that in 2005?
Keep it short and to the point. 0.97. What is the ratio of the Exports (in Local Currency Unit) of Mozambique in 2004 to that in 2005?
Give a very brief answer. 0.83. What is the ratio of the Exports (in Local Currency Unit) of United Arab Emirates in 2004 to that in 2005?
Offer a very short reply. 0.77. What is the ratio of the Exports (in Local Currency Unit) in Benin in 2004 to that in 2006?
Give a very brief answer. 0.9. What is the ratio of the Exports (in Local Currency Unit) in El Salvador in 2004 to that in 2006?
Provide a short and direct response. 0.89. What is the ratio of the Exports (in Local Currency Unit) in Mozambique in 2004 to that in 2006?
Make the answer very short. 0.7. What is the ratio of the Exports (in Local Currency Unit) in United Arab Emirates in 2004 to that in 2006?
Your response must be concise. 0.62. What is the ratio of the Exports (in Local Currency Unit) in Benin in 2005 to that in 2006?
Provide a succinct answer. 0.96. What is the ratio of the Exports (in Local Currency Unit) in El Salvador in 2005 to that in 2006?
Offer a very short reply. 0.92. What is the ratio of the Exports (in Local Currency Unit) of Mozambique in 2005 to that in 2006?
Offer a very short reply. 0.84. What is the ratio of the Exports (in Local Currency Unit) in United Arab Emirates in 2005 to that in 2006?
Your answer should be compact. 0.8. What is the difference between the highest and the second highest Exports (in Local Currency Unit) in Benin?
Provide a succinct answer. 1.85e+1. What is the difference between the highest and the second highest Exports (in Local Currency Unit) in El Salvador?
Your response must be concise. 3.81e+08. What is the difference between the highest and the second highest Exports (in Local Currency Unit) of Mozambique?
Your answer should be very brief. 1.00e+1. What is the difference between the highest and the second highest Exports (in Local Currency Unit) in United Arab Emirates?
Your answer should be compact. 1.12e+11. What is the difference between the highest and the lowest Exports (in Local Currency Unit) in Benin?
Provide a succinct answer. 9.84e+1. What is the difference between the highest and the lowest Exports (in Local Currency Unit) in El Salvador?
Your response must be concise. 1.20e+09. What is the difference between the highest and the lowest Exports (in Local Currency Unit) of Mozambique?
Give a very brief answer. 4.30e+1. What is the difference between the highest and the lowest Exports (in Local Currency Unit) of United Arab Emirates?
Your answer should be very brief. 3.73e+11. 